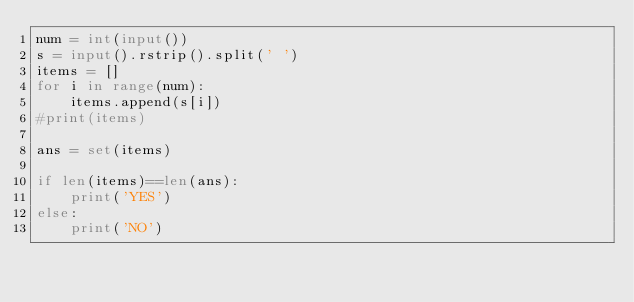<code> <loc_0><loc_0><loc_500><loc_500><_Python_>num = int(input())
s = input().rstrip().split(' ')
items = []
for i in range(num):
    items.append(s[i])
#print(items)

ans = set(items)

if len(items)==len(ans):
    print('YES')
else:
    print('NO')</code> 